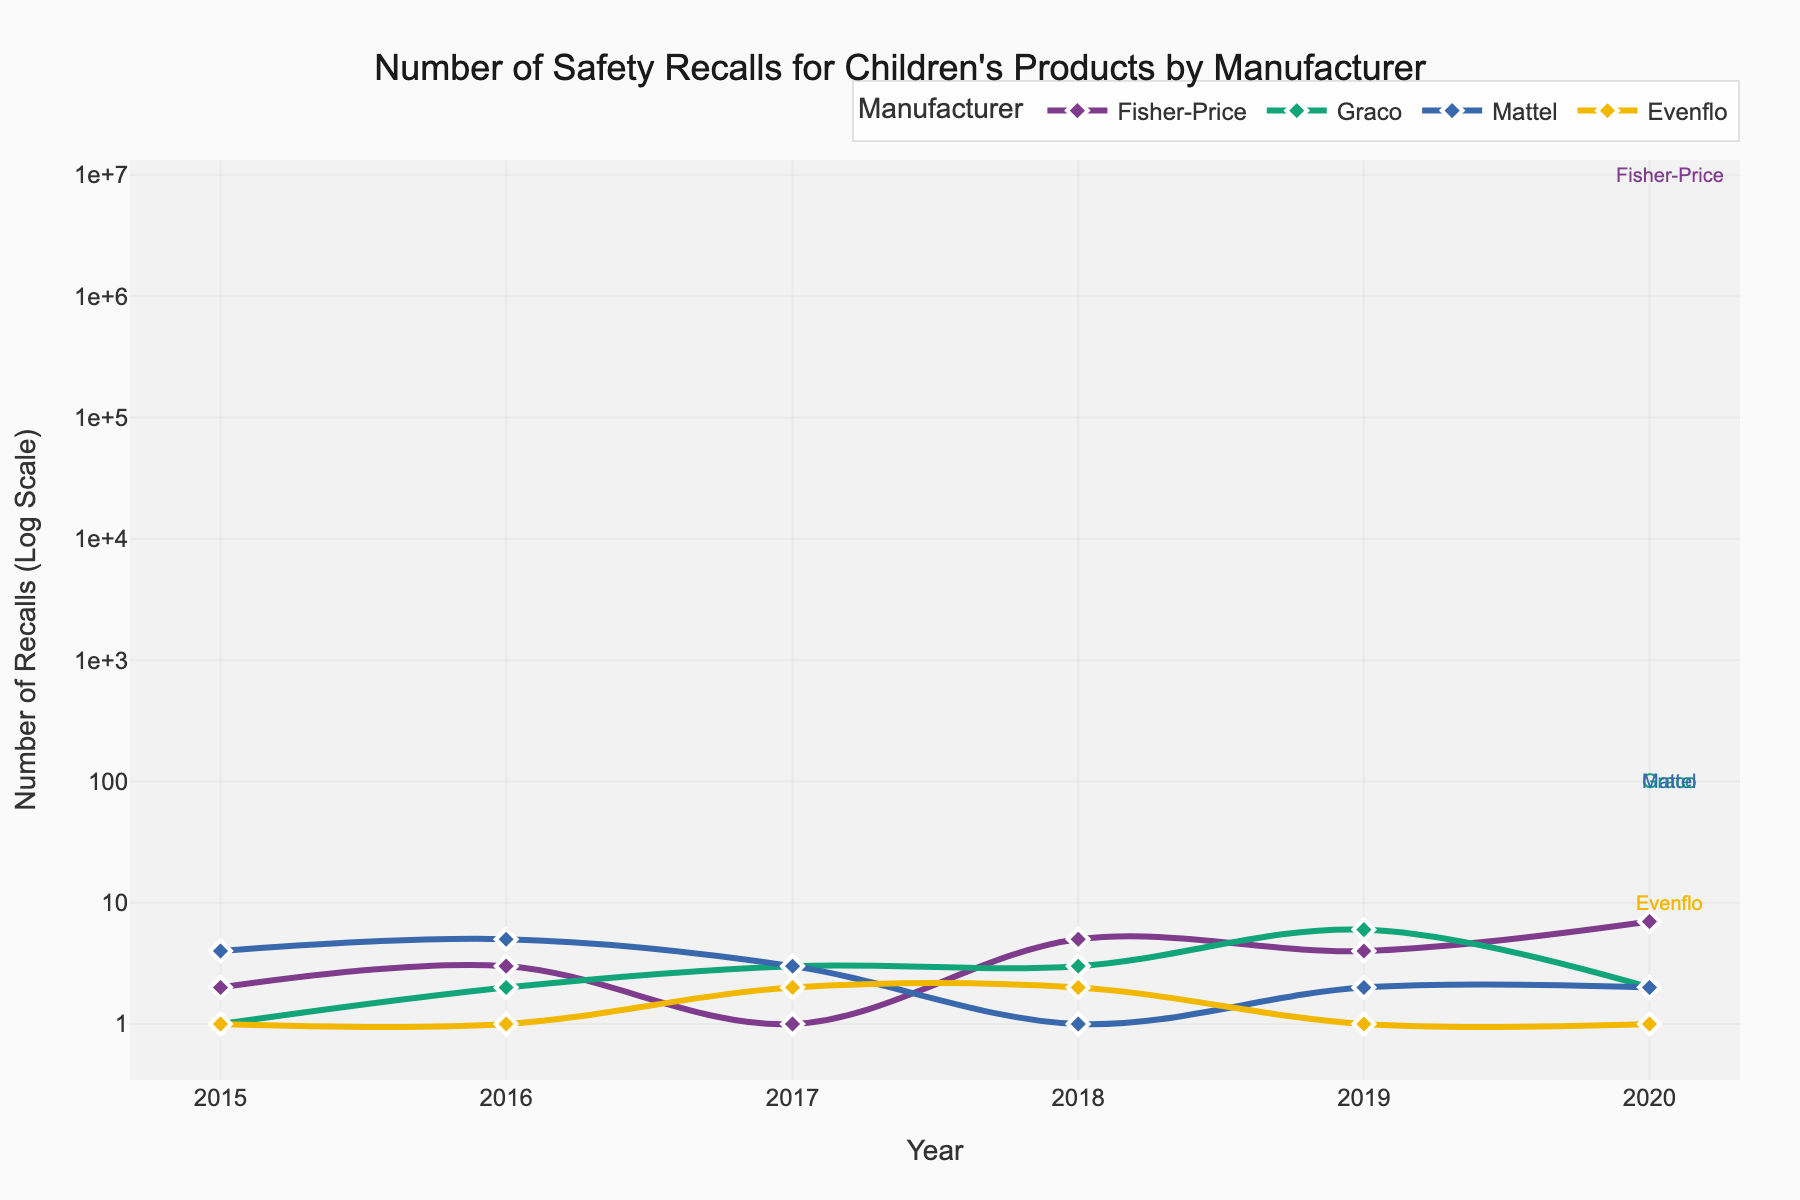What's the year with the highest number of recalls for Fisher-Price? To find this, look at Fisher-Price's line in the plot and identify the peak value on the vertical axis. The peak occurs in the year 2020 with 7 recalls.
Answer: 2020 Which manufacturer had the fewest recalls in 2020? Identify the number of recalls for each manufacturer in 2020 from the figure. Evenflo had only 1 recall, which is the fewest.
Answer: Evenflo How does the number of recalls for Graco in 2019 compare to 2020? Find the values for Graco in 2019 and 2020 from the plot. In 2019, Graco had 6 recalls and in 2020, it had 2 recalls. Therefore, the number of recalls decreased by 4.
Answer: Decreased by 4 What is the trend in the number of recalls for Mattel over the given years? Observing the line for Mattel over the years, the trend shows a decrease from 4 recalls in 2015 to 2 recalls in 2020, with fluctuations in between. The general trend is downward.
Answer: Downward trend Compared to Fisher-Price, how has Fisher-Price’s recall numbers changed from 2018 to 2020? In 2018, Fisher-Price had 5 recalls and in 2020 it had 7 recalls. This indicates an increase of 2 recalls.
Answer: Increased by 2 Which manufacturer had the most stable number of recalls over the six years? To determine stability, check the fluctuations in recalls for each manufacturer. Evenflo had relatively constant recalls with values of 1 or 2 each year, showing the most stability.
Answer: Evenflo What can you infer about Graco's recall pattern between 2018 and 2019? From the plot, Graco’s recalls increased significantly from 3 in 2018 to 6 in 2019.
Answer: Significant increase How many times did Fisher-Price have more than 3 recalls in any given year? Counting the years where Fisher-Price had more than 3 recalls from the plot: 2018 (5), 2019 (4), and 2020 (7) exceed 3, happening 3 times.
Answer: 3 times Which year did Mattel have its lowest number of recalls and how many? From the plot, Mattel had its lowest recalls in 2018, with 1 recall.
Answer: 2018, 1 recall 